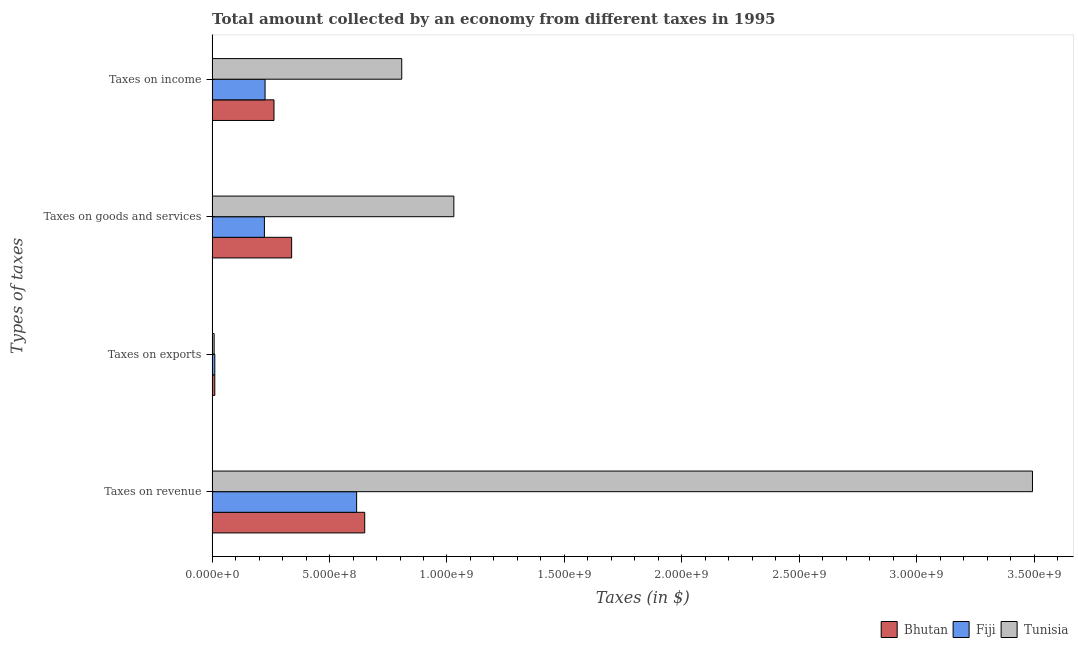How many bars are there on the 2nd tick from the top?
Your answer should be compact. 3. How many bars are there on the 1st tick from the bottom?
Your answer should be compact. 3. What is the label of the 2nd group of bars from the top?
Your answer should be compact. Taxes on goods and services. What is the amount collected as tax on income in Tunisia?
Ensure brevity in your answer.  8.07e+08. Across all countries, what is the maximum amount collected as tax on income?
Your answer should be compact. 8.07e+08. Across all countries, what is the minimum amount collected as tax on income?
Your answer should be compact. 2.25e+08. In which country was the amount collected as tax on income maximum?
Ensure brevity in your answer.  Tunisia. In which country was the amount collected as tax on goods minimum?
Provide a succinct answer. Fiji. What is the total amount collected as tax on exports in the graph?
Offer a terse response. 3.14e+07. What is the difference between the amount collected as tax on goods in Tunisia and that in Bhutan?
Offer a terse response. 6.91e+08. What is the difference between the amount collected as tax on exports in Bhutan and the amount collected as tax on income in Fiji?
Your answer should be very brief. -2.14e+08. What is the average amount collected as tax on exports per country?
Make the answer very short. 1.05e+07. What is the difference between the amount collected as tax on revenue and amount collected as tax on income in Fiji?
Your answer should be very brief. 3.90e+08. In how many countries, is the amount collected as tax on goods greater than 2300000000 $?
Your response must be concise. 0. What is the ratio of the amount collected as tax on revenue in Bhutan to that in Fiji?
Offer a very short reply. 1.06. Is the difference between the amount collected as tax on income in Fiji and Bhutan greater than the difference between the amount collected as tax on revenue in Fiji and Bhutan?
Keep it short and to the point. No. What is the difference between the highest and the second highest amount collected as tax on revenue?
Ensure brevity in your answer.  2.84e+09. What is the difference between the highest and the lowest amount collected as tax on exports?
Give a very brief answer. 2.80e+06. In how many countries, is the amount collected as tax on revenue greater than the average amount collected as tax on revenue taken over all countries?
Give a very brief answer. 1. Is the sum of the amount collected as tax on goods in Tunisia and Bhutan greater than the maximum amount collected as tax on exports across all countries?
Your response must be concise. Yes. Is it the case that in every country, the sum of the amount collected as tax on income and amount collected as tax on revenue is greater than the sum of amount collected as tax on exports and amount collected as tax on goods?
Ensure brevity in your answer.  No. What does the 2nd bar from the top in Taxes on goods and services represents?
Offer a terse response. Fiji. What does the 2nd bar from the bottom in Taxes on goods and services represents?
Offer a terse response. Fiji. Is it the case that in every country, the sum of the amount collected as tax on revenue and amount collected as tax on exports is greater than the amount collected as tax on goods?
Provide a short and direct response. Yes. How many countries are there in the graph?
Keep it short and to the point. 3. Does the graph contain any zero values?
Your answer should be compact. No. Where does the legend appear in the graph?
Make the answer very short. Bottom right. How many legend labels are there?
Your answer should be compact. 3. What is the title of the graph?
Offer a terse response. Total amount collected by an economy from different taxes in 1995. Does "Thailand" appear as one of the legend labels in the graph?
Make the answer very short. No. What is the label or title of the X-axis?
Your answer should be compact. Taxes (in $). What is the label or title of the Y-axis?
Provide a succinct answer. Types of taxes. What is the Taxes (in $) of Bhutan in Taxes on revenue?
Give a very brief answer. 6.50e+08. What is the Taxes (in $) of Fiji in Taxes on revenue?
Your answer should be compact. 6.15e+08. What is the Taxes (in $) of Tunisia in Taxes on revenue?
Provide a short and direct response. 3.49e+09. What is the Taxes (in $) in Bhutan in Taxes on exports?
Make the answer very short. 1.14e+07. What is the Taxes (in $) in Fiji in Taxes on exports?
Your response must be concise. 1.14e+07. What is the Taxes (in $) in Tunisia in Taxes on exports?
Keep it short and to the point. 8.60e+06. What is the Taxes (in $) of Bhutan in Taxes on goods and services?
Your answer should be compact. 3.39e+08. What is the Taxes (in $) of Fiji in Taxes on goods and services?
Offer a very short reply. 2.23e+08. What is the Taxes (in $) in Tunisia in Taxes on goods and services?
Your response must be concise. 1.03e+09. What is the Taxes (in $) in Bhutan in Taxes on income?
Your response must be concise. 2.64e+08. What is the Taxes (in $) of Fiji in Taxes on income?
Offer a very short reply. 2.25e+08. What is the Taxes (in $) in Tunisia in Taxes on income?
Offer a terse response. 8.07e+08. Across all Types of taxes, what is the maximum Taxes (in $) in Bhutan?
Give a very brief answer. 6.50e+08. Across all Types of taxes, what is the maximum Taxes (in $) of Fiji?
Offer a terse response. 6.15e+08. Across all Types of taxes, what is the maximum Taxes (in $) in Tunisia?
Make the answer very short. 3.49e+09. Across all Types of taxes, what is the minimum Taxes (in $) in Bhutan?
Your answer should be very brief. 1.14e+07. Across all Types of taxes, what is the minimum Taxes (in $) of Fiji?
Give a very brief answer. 1.14e+07. Across all Types of taxes, what is the minimum Taxes (in $) in Tunisia?
Make the answer very short. 8.60e+06. What is the total Taxes (in $) of Bhutan in the graph?
Offer a very short reply. 1.26e+09. What is the total Taxes (in $) in Fiji in the graph?
Your answer should be very brief. 1.07e+09. What is the total Taxes (in $) of Tunisia in the graph?
Your response must be concise. 5.34e+09. What is the difference between the Taxes (in $) in Bhutan in Taxes on revenue and that in Taxes on exports?
Give a very brief answer. 6.38e+08. What is the difference between the Taxes (in $) in Fiji in Taxes on revenue and that in Taxes on exports?
Your answer should be very brief. 6.04e+08. What is the difference between the Taxes (in $) in Tunisia in Taxes on revenue and that in Taxes on exports?
Ensure brevity in your answer.  3.48e+09. What is the difference between the Taxes (in $) of Bhutan in Taxes on revenue and that in Taxes on goods and services?
Keep it short and to the point. 3.11e+08. What is the difference between the Taxes (in $) of Fiji in Taxes on revenue and that in Taxes on goods and services?
Your answer should be very brief. 3.93e+08. What is the difference between the Taxes (in $) in Tunisia in Taxes on revenue and that in Taxes on goods and services?
Your response must be concise. 2.46e+09. What is the difference between the Taxes (in $) in Bhutan in Taxes on revenue and that in Taxes on income?
Provide a short and direct response. 3.86e+08. What is the difference between the Taxes (in $) in Fiji in Taxes on revenue and that in Taxes on income?
Your answer should be very brief. 3.90e+08. What is the difference between the Taxes (in $) in Tunisia in Taxes on revenue and that in Taxes on income?
Give a very brief answer. 2.69e+09. What is the difference between the Taxes (in $) in Bhutan in Taxes on exports and that in Taxes on goods and services?
Ensure brevity in your answer.  -3.27e+08. What is the difference between the Taxes (in $) in Fiji in Taxes on exports and that in Taxes on goods and services?
Your answer should be very brief. -2.11e+08. What is the difference between the Taxes (in $) in Tunisia in Taxes on exports and that in Taxes on goods and services?
Offer a terse response. -1.02e+09. What is the difference between the Taxes (in $) in Bhutan in Taxes on exports and that in Taxes on income?
Make the answer very short. -2.52e+08. What is the difference between the Taxes (in $) of Fiji in Taxes on exports and that in Taxes on income?
Offer a very short reply. -2.14e+08. What is the difference between the Taxes (in $) in Tunisia in Taxes on exports and that in Taxes on income?
Give a very brief answer. -7.99e+08. What is the difference between the Taxes (in $) in Bhutan in Taxes on goods and services and that in Taxes on income?
Your answer should be compact. 7.51e+07. What is the difference between the Taxes (in $) of Fiji in Taxes on goods and services and that in Taxes on income?
Make the answer very short. -2.87e+06. What is the difference between the Taxes (in $) in Tunisia in Taxes on goods and services and that in Taxes on income?
Keep it short and to the point. 2.22e+08. What is the difference between the Taxes (in $) in Bhutan in Taxes on revenue and the Taxes (in $) in Fiji in Taxes on exports?
Your answer should be compact. 6.38e+08. What is the difference between the Taxes (in $) of Bhutan in Taxes on revenue and the Taxes (in $) of Tunisia in Taxes on exports?
Keep it short and to the point. 6.41e+08. What is the difference between the Taxes (in $) of Fiji in Taxes on revenue and the Taxes (in $) of Tunisia in Taxes on exports?
Your answer should be compact. 6.07e+08. What is the difference between the Taxes (in $) in Bhutan in Taxes on revenue and the Taxes (in $) in Fiji in Taxes on goods and services?
Your response must be concise. 4.27e+08. What is the difference between the Taxes (in $) in Bhutan in Taxes on revenue and the Taxes (in $) in Tunisia in Taxes on goods and services?
Give a very brief answer. -3.80e+08. What is the difference between the Taxes (in $) in Fiji in Taxes on revenue and the Taxes (in $) in Tunisia in Taxes on goods and services?
Provide a short and direct response. -4.14e+08. What is the difference between the Taxes (in $) in Bhutan in Taxes on revenue and the Taxes (in $) in Fiji in Taxes on income?
Offer a very short reply. 4.24e+08. What is the difference between the Taxes (in $) of Bhutan in Taxes on revenue and the Taxes (in $) of Tunisia in Taxes on income?
Ensure brevity in your answer.  -1.58e+08. What is the difference between the Taxes (in $) of Fiji in Taxes on revenue and the Taxes (in $) of Tunisia in Taxes on income?
Offer a terse response. -1.92e+08. What is the difference between the Taxes (in $) of Bhutan in Taxes on exports and the Taxes (in $) of Fiji in Taxes on goods and services?
Your answer should be very brief. -2.11e+08. What is the difference between the Taxes (in $) of Bhutan in Taxes on exports and the Taxes (in $) of Tunisia in Taxes on goods and services?
Offer a terse response. -1.02e+09. What is the difference between the Taxes (in $) of Fiji in Taxes on exports and the Taxes (in $) of Tunisia in Taxes on goods and services?
Provide a succinct answer. -1.02e+09. What is the difference between the Taxes (in $) of Bhutan in Taxes on exports and the Taxes (in $) of Fiji in Taxes on income?
Offer a very short reply. -2.14e+08. What is the difference between the Taxes (in $) of Bhutan in Taxes on exports and the Taxes (in $) of Tunisia in Taxes on income?
Your answer should be very brief. -7.96e+08. What is the difference between the Taxes (in $) in Fiji in Taxes on exports and the Taxes (in $) in Tunisia in Taxes on income?
Give a very brief answer. -7.96e+08. What is the difference between the Taxes (in $) in Bhutan in Taxes on goods and services and the Taxes (in $) in Fiji in Taxes on income?
Give a very brief answer. 1.13e+08. What is the difference between the Taxes (in $) of Bhutan in Taxes on goods and services and the Taxes (in $) of Tunisia in Taxes on income?
Offer a terse response. -4.69e+08. What is the difference between the Taxes (in $) in Fiji in Taxes on goods and services and the Taxes (in $) in Tunisia in Taxes on income?
Ensure brevity in your answer.  -5.85e+08. What is the average Taxes (in $) in Bhutan per Types of taxes?
Give a very brief answer. 3.16e+08. What is the average Taxes (in $) of Fiji per Types of taxes?
Provide a succinct answer. 2.69e+08. What is the average Taxes (in $) in Tunisia per Types of taxes?
Ensure brevity in your answer.  1.33e+09. What is the difference between the Taxes (in $) of Bhutan and Taxes (in $) of Fiji in Taxes on revenue?
Your answer should be compact. 3.45e+07. What is the difference between the Taxes (in $) of Bhutan and Taxes (in $) of Tunisia in Taxes on revenue?
Keep it short and to the point. -2.84e+09. What is the difference between the Taxes (in $) in Fiji and Taxes (in $) in Tunisia in Taxes on revenue?
Your answer should be compact. -2.88e+09. What is the difference between the Taxes (in $) in Bhutan and Taxes (in $) in Tunisia in Taxes on exports?
Your answer should be compact. 2.80e+06. What is the difference between the Taxes (in $) of Fiji and Taxes (in $) of Tunisia in Taxes on exports?
Provide a short and direct response. 2.78e+06. What is the difference between the Taxes (in $) in Bhutan and Taxes (in $) in Fiji in Taxes on goods and services?
Ensure brevity in your answer.  1.16e+08. What is the difference between the Taxes (in $) of Bhutan and Taxes (in $) of Tunisia in Taxes on goods and services?
Offer a very short reply. -6.91e+08. What is the difference between the Taxes (in $) of Fiji and Taxes (in $) of Tunisia in Taxes on goods and services?
Ensure brevity in your answer.  -8.07e+08. What is the difference between the Taxes (in $) in Bhutan and Taxes (in $) in Fiji in Taxes on income?
Offer a terse response. 3.80e+07. What is the difference between the Taxes (in $) in Bhutan and Taxes (in $) in Tunisia in Taxes on income?
Your response must be concise. -5.44e+08. What is the difference between the Taxes (in $) in Fiji and Taxes (in $) in Tunisia in Taxes on income?
Offer a terse response. -5.82e+08. What is the ratio of the Taxes (in $) of Fiji in Taxes on revenue to that in Taxes on exports?
Your answer should be compact. 54.07. What is the ratio of the Taxes (in $) of Tunisia in Taxes on revenue to that in Taxes on exports?
Your response must be concise. 406.19. What is the ratio of the Taxes (in $) in Bhutan in Taxes on revenue to that in Taxes on goods and services?
Your response must be concise. 1.92. What is the ratio of the Taxes (in $) in Fiji in Taxes on revenue to that in Taxes on goods and services?
Offer a terse response. 2.76. What is the ratio of the Taxes (in $) in Tunisia in Taxes on revenue to that in Taxes on goods and services?
Offer a very short reply. 3.39. What is the ratio of the Taxes (in $) of Bhutan in Taxes on revenue to that in Taxes on income?
Offer a very short reply. 2.47. What is the ratio of the Taxes (in $) of Fiji in Taxes on revenue to that in Taxes on income?
Your answer should be very brief. 2.73. What is the ratio of the Taxes (in $) in Tunisia in Taxes on revenue to that in Taxes on income?
Provide a short and direct response. 4.33. What is the ratio of the Taxes (in $) of Bhutan in Taxes on exports to that in Taxes on goods and services?
Keep it short and to the point. 0.03. What is the ratio of the Taxes (in $) in Fiji in Taxes on exports to that in Taxes on goods and services?
Your answer should be very brief. 0.05. What is the ratio of the Taxes (in $) in Tunisia in Taxes on exports to that in Taxes on goods and services?
Your answer should be very brief. 0.01. What is the ratio of the Taxes (in $) of Bhutan in Taxes on exports to that in Taxes on income?
Offer a terse response. 0.04. What is the ratio of the Taxes (in $) of Fiji in Taxes on exports to that in Taxes on income?
Make the answer very short. 0.05. What is the ratio of the Taxes (in $) in Tunisia in Taxes on exports to that in Taxes on income?
Keep it short and to the point. 0.01. What is the ratio of the Taxes (in $) in Bhutan in Taxes on goods and services to that in Taxes on income?
Provide a succinct answer. 1.28. What is the ratio of the Taxes (in $) of Fiji in Taxes on goods and services to that in Taxes on income?
Keep it short and to the point. 0.99. What is the ratio of the Taxes (in $) in Tunisia in Taxes on goods and services to that in Taxes on income?
Give a very brief answer. 1.27. What is the difference between the highest and the second highest Taxes (in $) in Bhutan?
Ensure brevity in your answer.  3.11e+08. What is the difference between the highest and the second highest Taxes (in $) in Fiji?
Your response must be concise. 3.90e+08. What is the difference between the highest and the second highest Taxes (in $) in Tunisia?
Offer a terse response. 2.46e+09. What is the difference between the highest and the lowest Taxes (in $) of Bhutan?
Provide a short and direct response. 6.38e+08. What is the difference between the highest and the lowest Taxes (in $) of Fiji?
Provide a succinct answer. 6.04e+08. What is the difference between the highest and the lowest Taxes (in $) in Tunisia?
Your response must be concise. 3.48e+09. 